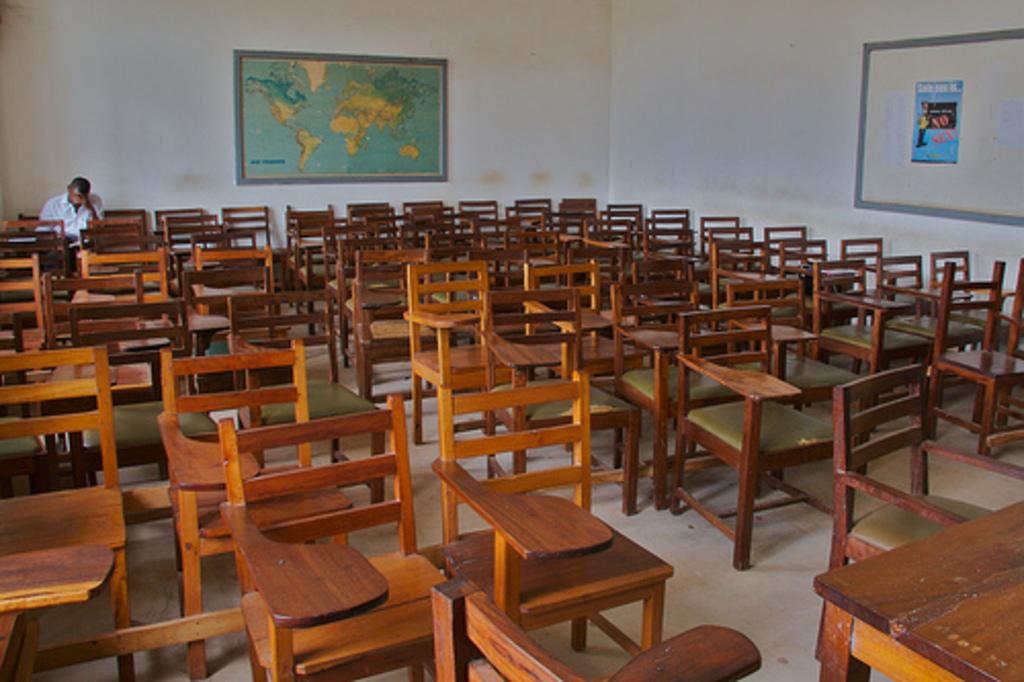What type of space is depicted in the image? The image is of a room. What furniture can be seen in the room? There are chairs in the room. Is there anyone present in the room? Yes, there is a person sitting in the room. What is the purpose of the board in the room? The purpose of the board in the room is not specified in the facts, but it is present in the image. What decoration is on the wall in the room? There is a poster on the wall in the room. How many dolls are sitting on the person's lap in the image? There are no dolls present in the image; only a person sitting in the room is mentioned. 